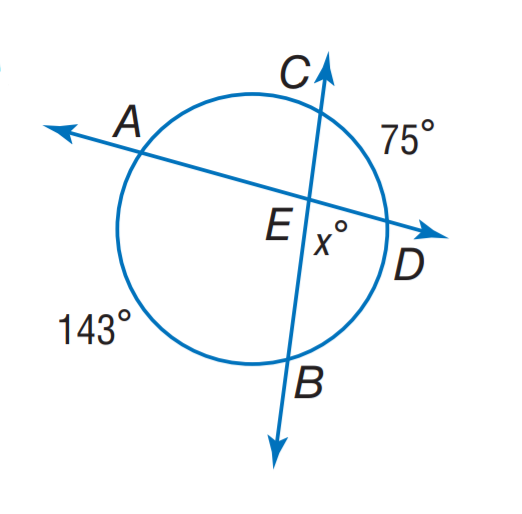Answer the mathemtical geometry problem and directly provide the correct option letter.
Question: Find m \angle A E B.
Choices: A: 71 B: 109 C: 142 D: 143 B 